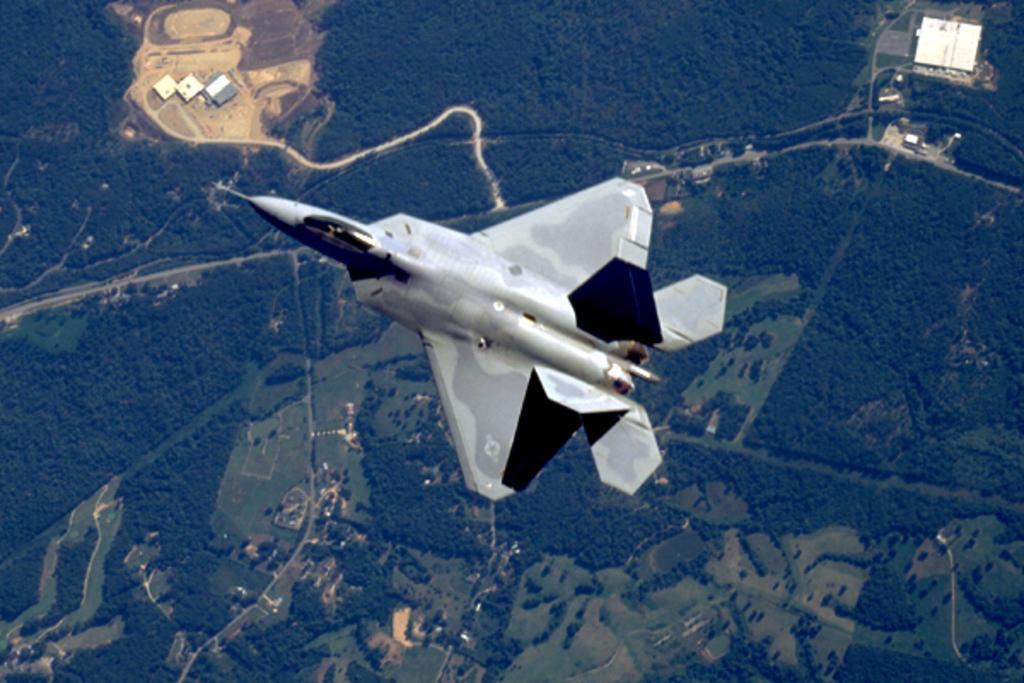What is the main subject of the image? The main subject of the image is a plane. What is the background of the image? There is a top view of the earth in the image. What type of natural features can be seen on the earth in the image? Trees are visible on the earth in the image. What type of man-made structures can be seen on the earth in the image? Buildings are visible on the earth in the image. Can you see an ant carrying an umbrella in the image? There is no ant or umbrella present in the image. Who is the servant attending to in the image? There is no servant present in the image. 